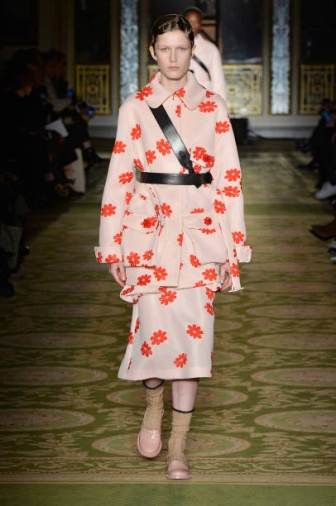What is this photo about? The photo captures a moment from a high-end fashion show set in an opulent room adorned with intricate gold details. At the center, a model walks confidently down a striking green runway, which is bordered by an attentive audience seated on either side. The model is dressed in an eye-catching pink dress, embellished with vibrant red flowers that add a contrasting pop of color. A black sash cinches the waist, creating a defined silhouette. Adding a unique twist, the model wears pink socks with beige heels. The luxurious backdrop of the room enhances the elegance and exclusivity of the event, making the fashion show a captivating spectacle. 